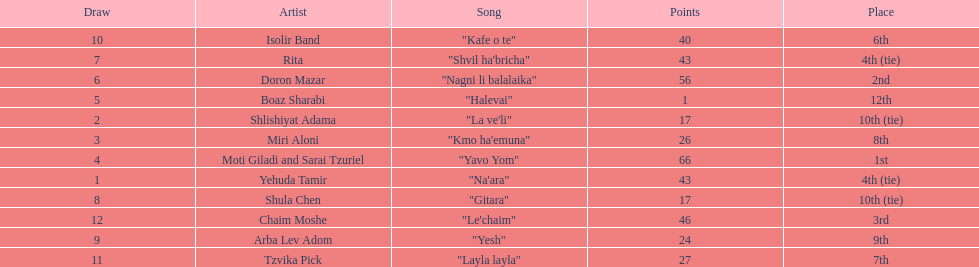What song is listed in the table right before layla layla? "Kafe o te". 